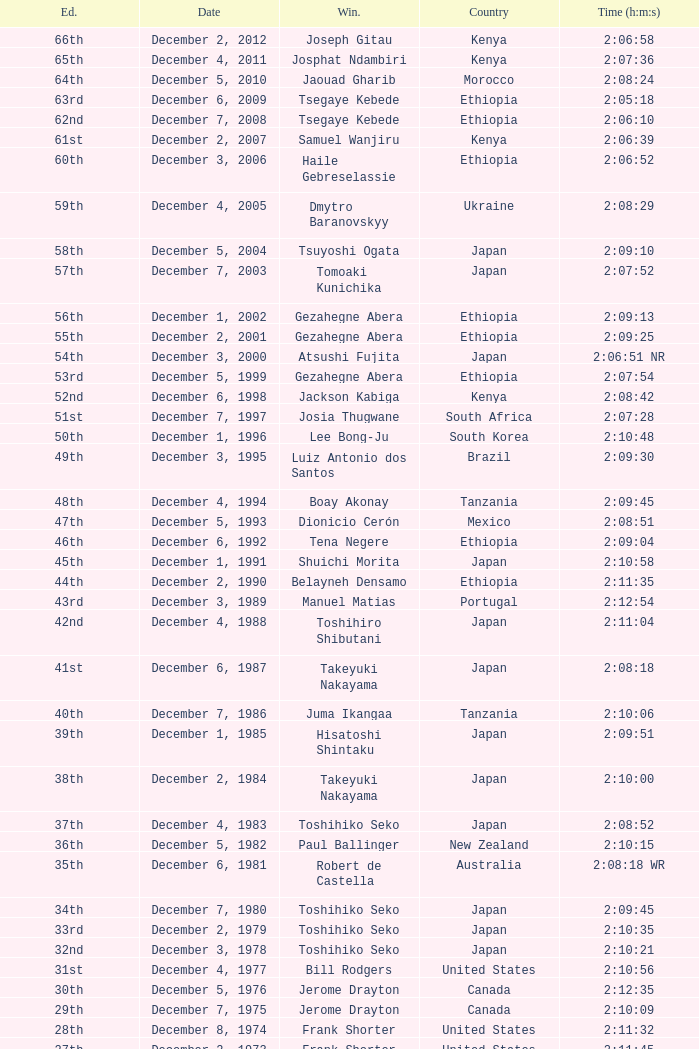What was the nationality of the winner of the 42nd Edition? Japan. 